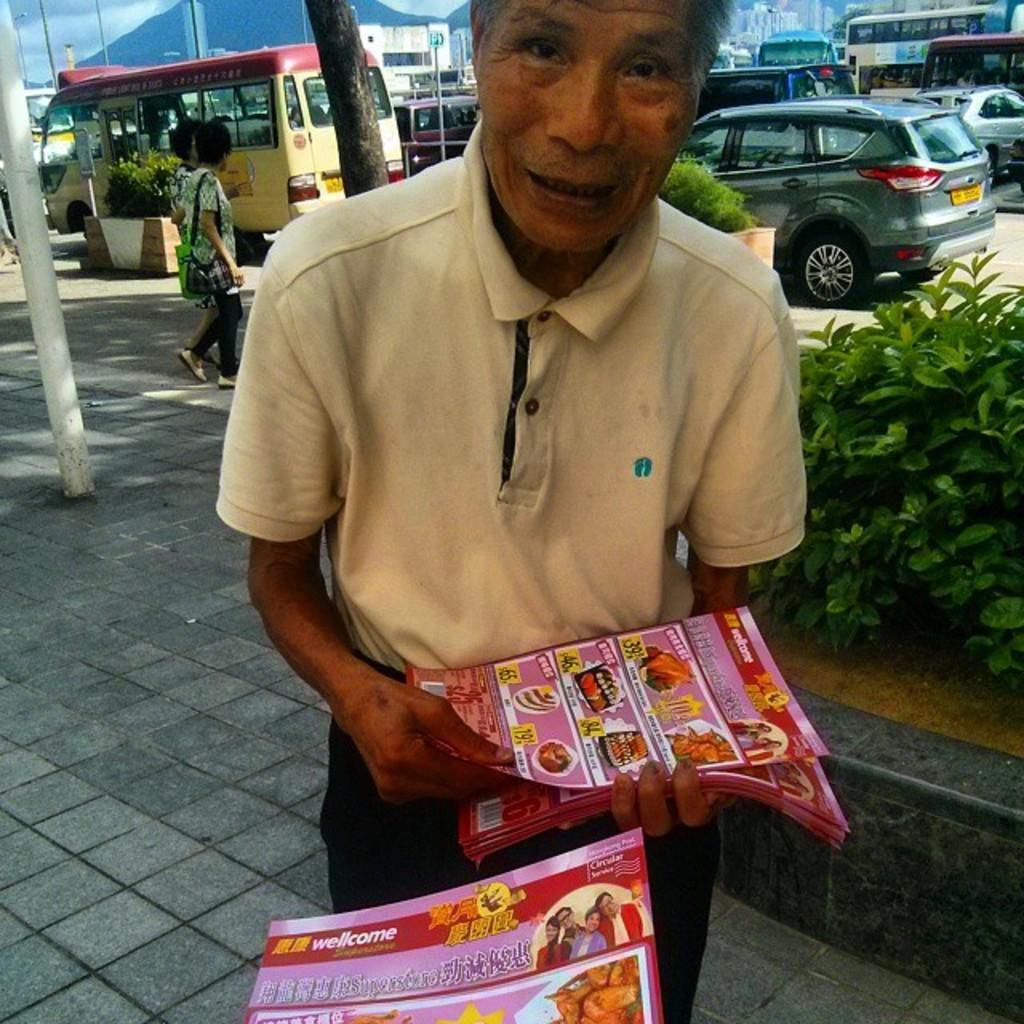Please provide a concise description of this image. In this picture, there is a man holding pamphlets. He is wearing a light yellow t shirt. Towards the right, there are plants. Behind the person, there are people, vehicles, hills, poles etc. 